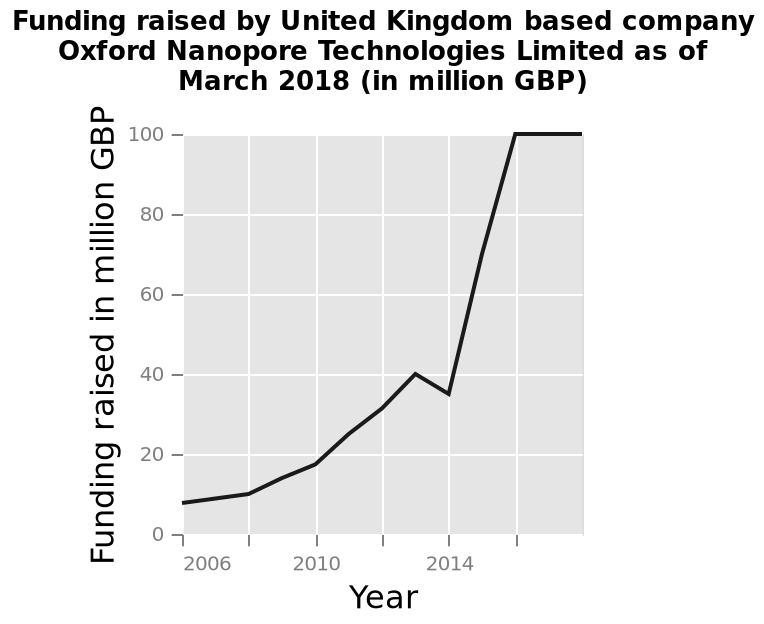<image>
please describe the details of the chart Funding raised by United Kingdom based company Oxford Nanopore Technologies Limited as of March 2018 (in million GBP) is a line graph. The x-axis shows Year using linear scale from 2006 to 2016 while the y-axis plots Funding raised in million GBP using linear scale with a minimum of 0 and a maximum of 100. What was the funding raised by Oxford Nanopore Technologies Limited in 2006?  The funding raised by Oxford Nanopore Technologies Limited in 2006 was less than ten million British pounds. Offer a thorough analysis of the image. The graph represents an increase in the funding raised by the United Kingdon between years 2006 and 2018. There was a slight decrease between year 2013 and 2014, although after the year 2014, a significant increase from less than 40 million GBP to 100 million GBP was observed. What was the percentage increase in funding raised by Oxford Nanopore Technologies Limited from 2006 to 2018? The funding raised increased by about 1000% from less than ten million British pounds in 2006 to 100 million British pounds in 2018. Was the funding raised by Oxford Nanopore Technologies Limited in 2006 more than ten million British pounds? No. The funding raised by Oxford Nanopore Technologies Limited in 2006 was less than ten million British pounds. 